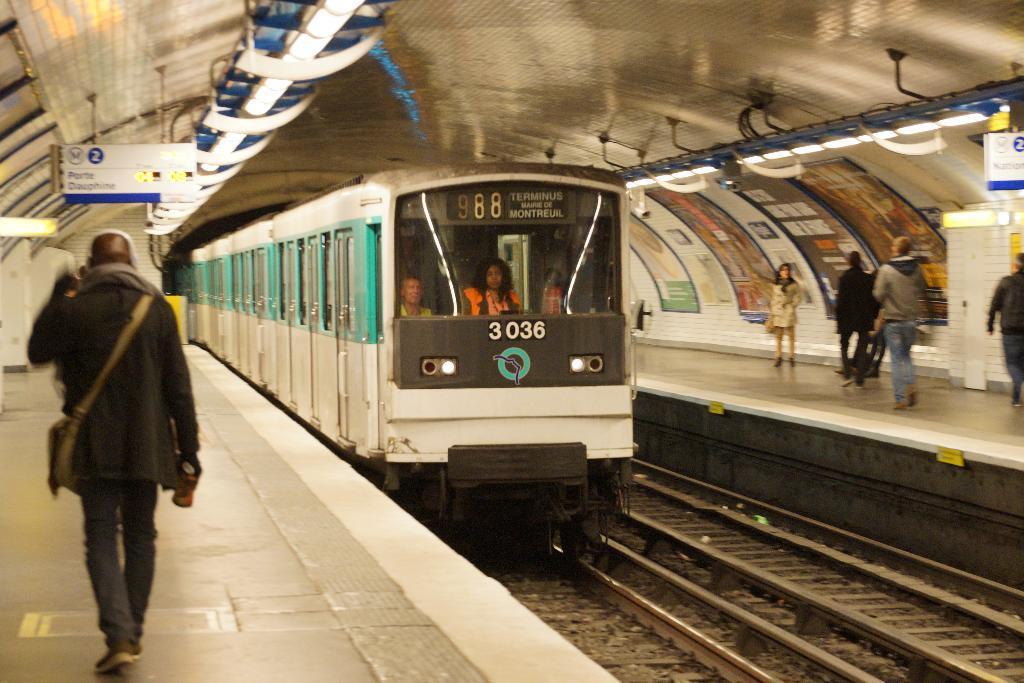Describe this image in one or two sentences. In the image we can see the train on the train track. In the train we can see there are people sitting. We can even see there are other people and some of them are standing, they are wearing clothes and they are carrying bags. Here we can see the lights and the posters.  